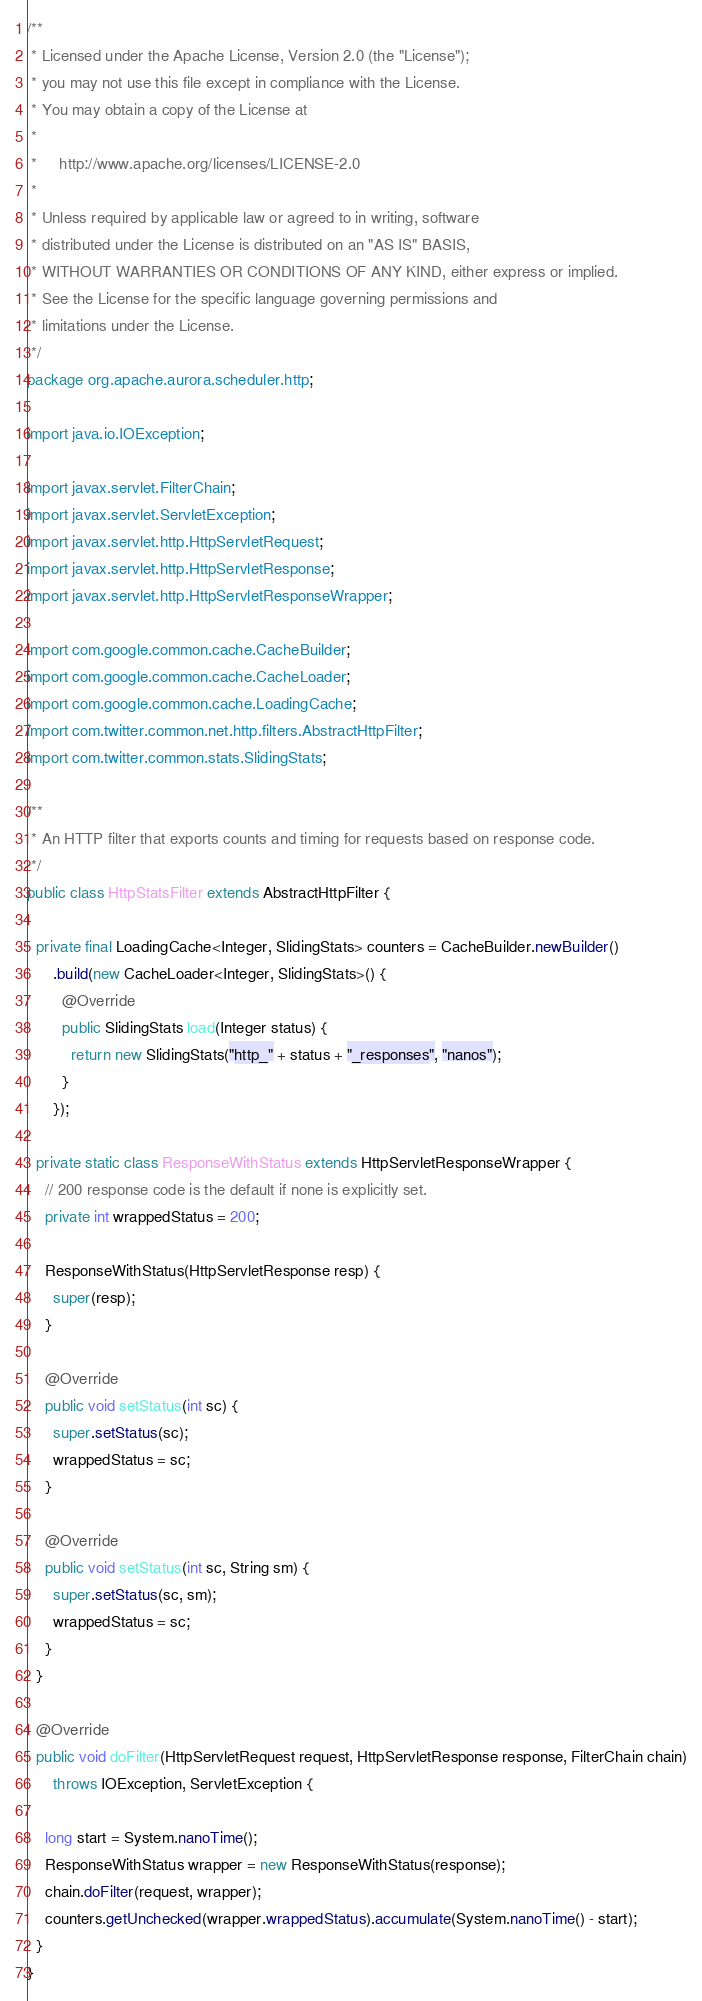Convert code to text. <code><loc_0><loc_0><loc_500><loc_500><_Java_>/**
 * Licensed under the Apache License, Version 2.0 (the "License");
 * you may not use this file except in compliance with the License.
 * You may obtain a copy of the License at
 *
 *     http://www.apache.org/licenses/LICENSE-2.0
 *
 * Unless required by applicable law or agreed to in writing, software
 * distributed under the License is distributed on an "AS IS" BASIS,
 * WITHOUT WARRANTIES OR CONDITIONS OF ANY KIND, either express or implied.
 * See the License for the specific language governing permissions and
 * limitations under the License.
 */
package org.apache.aurora.scheduler.http;

import java.io.IOException;

import javax.servlet.FilterChain;
import javax.servlet.ServletException;
import javax.servlet.http.HttpServletRequest;
import javax.servlet.http.HttpServletResponse;
import javax.servlet.http.HttpServletResponseWrapper;

import com.google.common.cache.CacheBuilder;
import com.google.common.cache.CacheLoader;
import com.google.common.cache.LoadingCache;
import com.twitter.common.net.http.filters.AbstractHttpFilter;
import com.twitter.common.stats.SlidingStats;

/**
 * An HTTP filter that exports counts and timing for requests based on response code.
 */
public class HttpStatsFilter extends AbstractHttpFilter {

  private final LoadingCache<Integer, SlidingStats> counters = CacheBuilder.newBuilder()
      .build(new CacheLoader<Integer, SlidingStats>() {
        @Override
        public SlidingStats load(Integer status) {
          return new SlidingStats("http_" + status + "_responses", "nanos");
        }
      });

  private static class ResponseWithStatus extends HttpServletResponseWrapper {
    // 200 response code is the default if none is explicitly set.
    private int wrappedStatus = 200;

    ResponseWithStatus(HttpServletResponse resp) {
      super(resp);
    }

    @Override
    public void setStatus(int sc) {
      super.setStatus(sc);
      wrappedStatus = sc;
    }

    @Override
    public void setStatus(int sc, String sm) {
      super.setStatus(sc, sm);
      wrappedStatus = sc;
    }
  }

  @Override
  public void doFilter(HttpServletRequest request, HttpServletResponse response, FilterChain chain)
      throws IOException, ServletException {

    long start = System.nanoTime();
    ResponseWithStatus wrapper = new ResponseWithStatus(response);
    chain.doFilter(request, wrapper);
    counters.getUnchecked(wrapper.wrappedStatus).accumulate(System.nanoTime() - start);
  }
}
</code> 